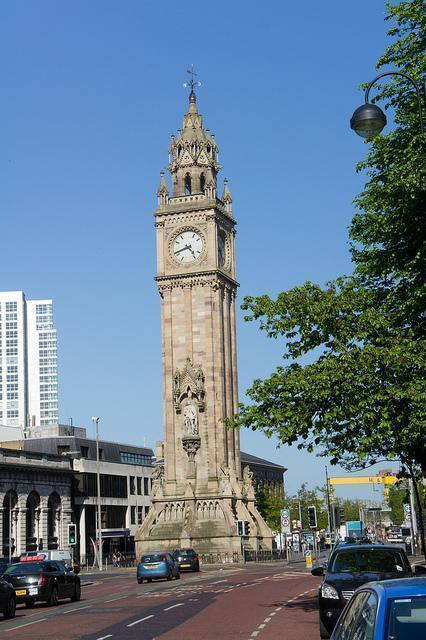What is near the tower?
Indicate the correct response by choosing from the four available options to answer the question.
Options: Car, airplane, princess, baby. Car. 